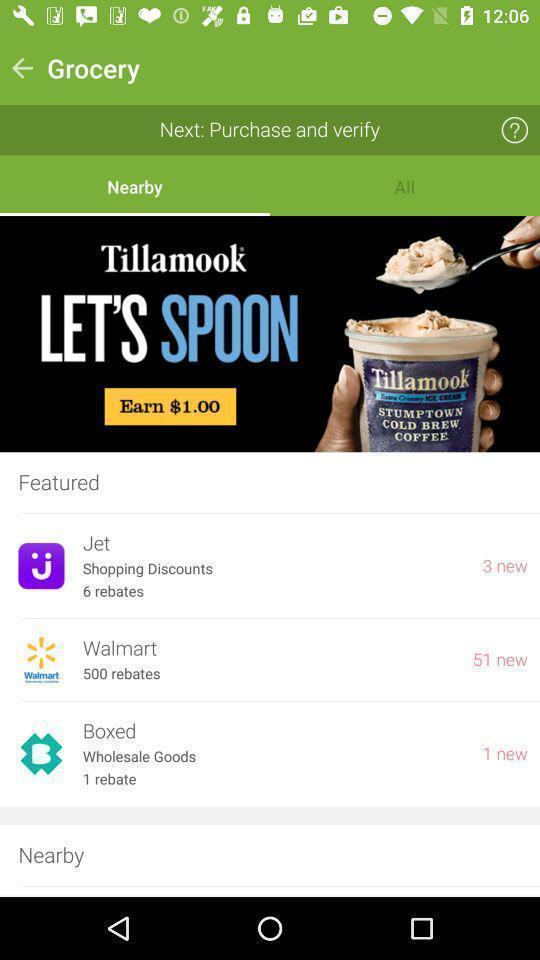What details can you identify in this image? Page showing multiple shopping app. 